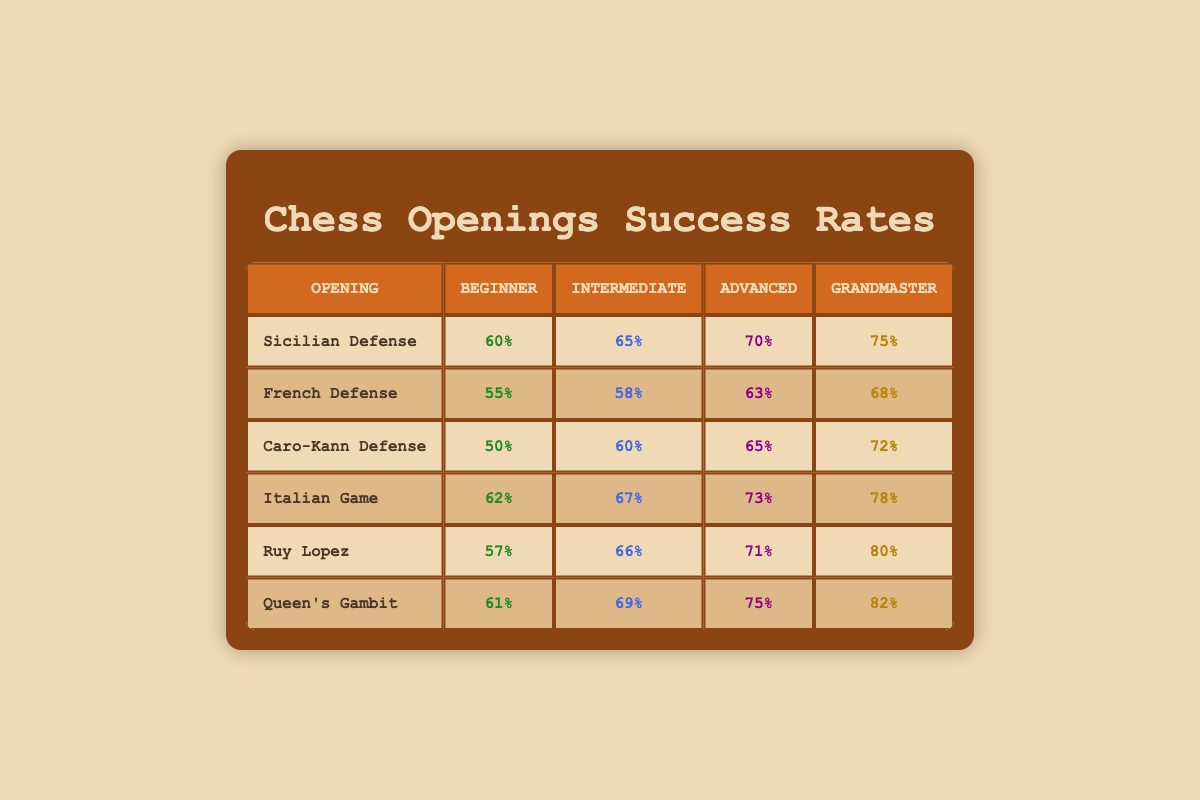What is the success rate of the Sicilian Defense for advanced players? The success rate for advanced players is listed in the table under the Sicilian Defense row. The value is 70%.
Answer: 70% Which opening has the highest success rate for beginners? To find the highest success rate for beginners, I compare the beginner success rates for all the openings listed. The opening with the highest rate is the Italian Game at 62%.
Answer: Italian Game Is the success rate of the Ruy Lopez higher than that of the French Defense for grandmasters? The success rates for grandmasters in the table are 80% for Ruy Lopez and 68% for French Defense. Since 80% is greater than 68%, the statement is true.
Answer: Yes What is the average success rate for intermediate players across all openings? First, I sum the success rates for intermediate players: 65 + 58 + 60 + 67 + 66 + 69 = 405. Then, I divide by the number of openings (6): 405/6 = 67.5.
Answer: 67.5 Which openings have a success rate of 70% or more for grandmasters? I check the grandmaster success rates for all openings. The ones with 70% or more are Sicilian Defense (75%), Italian Game (78%), Ruy Lopez (80%), and Queen's Gambit (82%).
Answer: Sicilian Defense, Italian Game, Ruy Lopez, Queen's Gambit What is the difference in success rates between the Caro-Kann Defense and the Italian Game for intermediate players? The intermediate success rate for Caro-Kann Defense is 60%, and for Italian Game, it is 67%. The difference is 67 - 60 = 7.
Answer: 7 Which opening shows the least improvement in success rate from beginner to grandmaster levels? I analyze the improvement from beginner to grandmaster for each opening. The French Defense improves by 13% (55% to 68%), while the Caro-Kann Defense improves by 22% (50% to 72%). The least improvement is thus 13%.
Answer: 13% Does any opening show a consistent increase in success rates across all levels? By inspecting the table, I can see that the Italian Game shows a consistent increase from 62% for beginners, to 67% for intermediate, to 73% for advanced, and finally to 78% for grandmasters.
Answer: Yes 